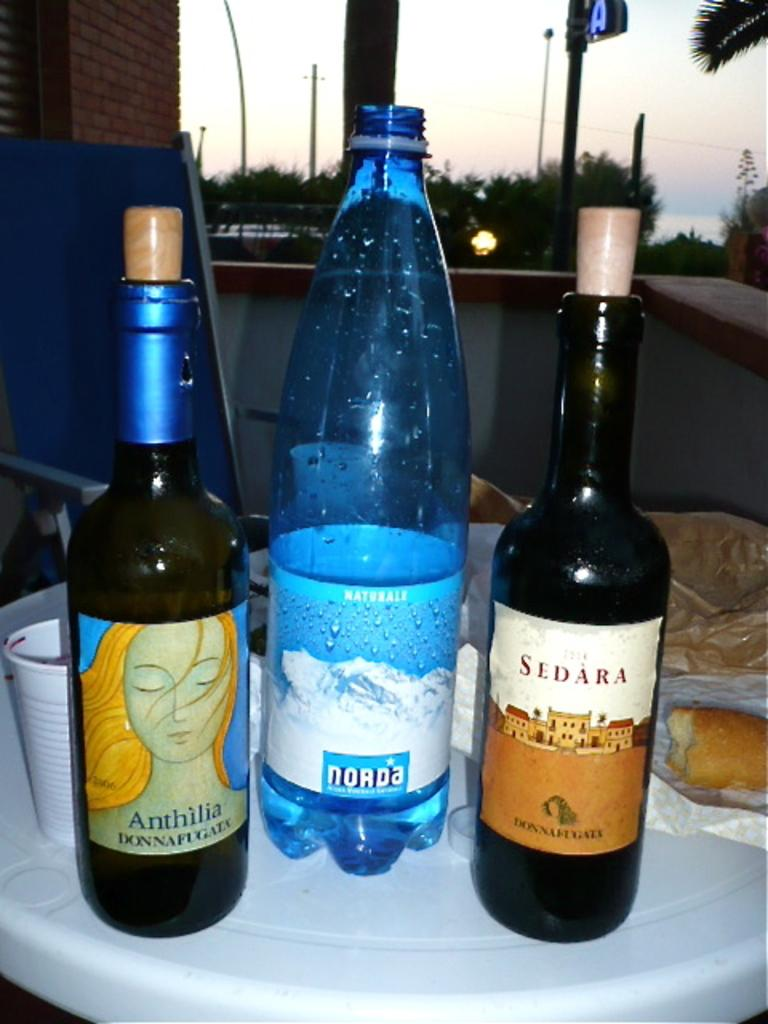<image>
Write a terse but informative summary of the picture. A bottle of Sedara and Anthilia sit next to a water bottle. 